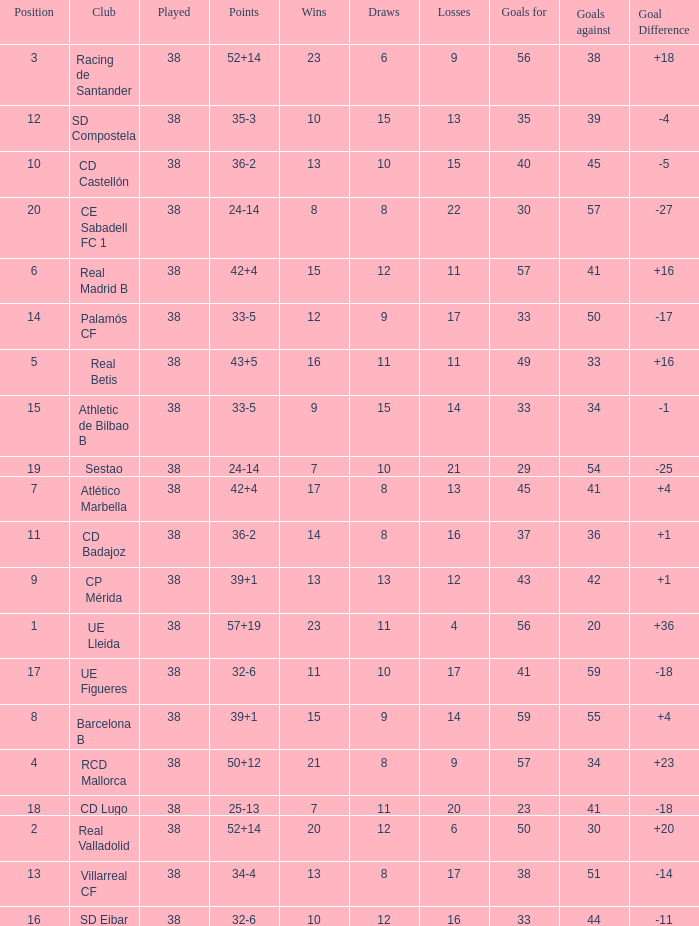What is the highest position with less than 17 losses, more than 57 goals, and a goal difference less than 4? None. 